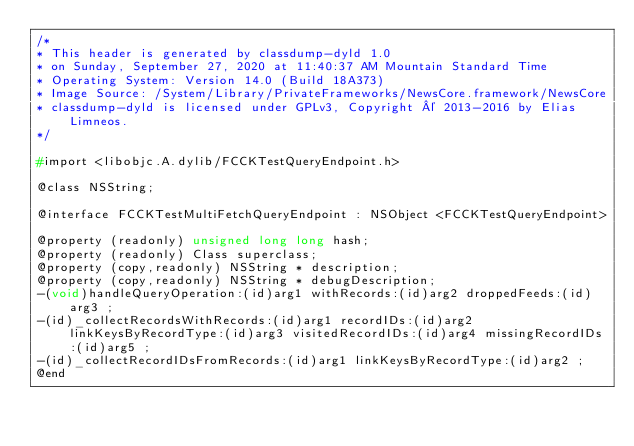<code> <loc_0><loc_0><loc_500><loc_500><_C_>/*
* This header is generated by classdump-dyld 1.0
* on Sunday, September 27, 2020 at 11:40:37 AM Mountain Standard Time
* Operating System: Version 14.0 (Build 18A373)
* Image Source: /System/Library/PrivateFrameworks/NewsCore.framework/NewsCore
* classdump-dyld is licensed under GPLv3, Copyright © 2013-2016 by Elias Limneos.
*/

#import <libobjc.A.dylib/FCCKTestQueryEndpoint.h>

@class NSString;

@interface FCCKTestMultiFetchQueryEndpoint : NSObject <FCCKTestQueryEndpoint>

@property (readonly) unsigned long long hash; 
@property (readonly) Class superclass; 
@property (copy,readonly) NSString * description; 
@property (copy,readonly) NSString * debugDescription; 
-(void)handleQueryOperation:(id)arg1 withRecords:(id)arg2 droppedFeeds:(id)arg3 ;
-(id)_collectRecordsWithRecords:(id)arg1 recordIDs:(id)arg2 linkKeysByRecordType:(id)arg3 visitedRecordIDs:(id)arg4 missingRecordIDs:(id)arg5 ;
-(id)_collectRecordIDsFromRecords:(id)arg1 linkKeysByRecordType:(id)arg2 ;
@end

</code> 